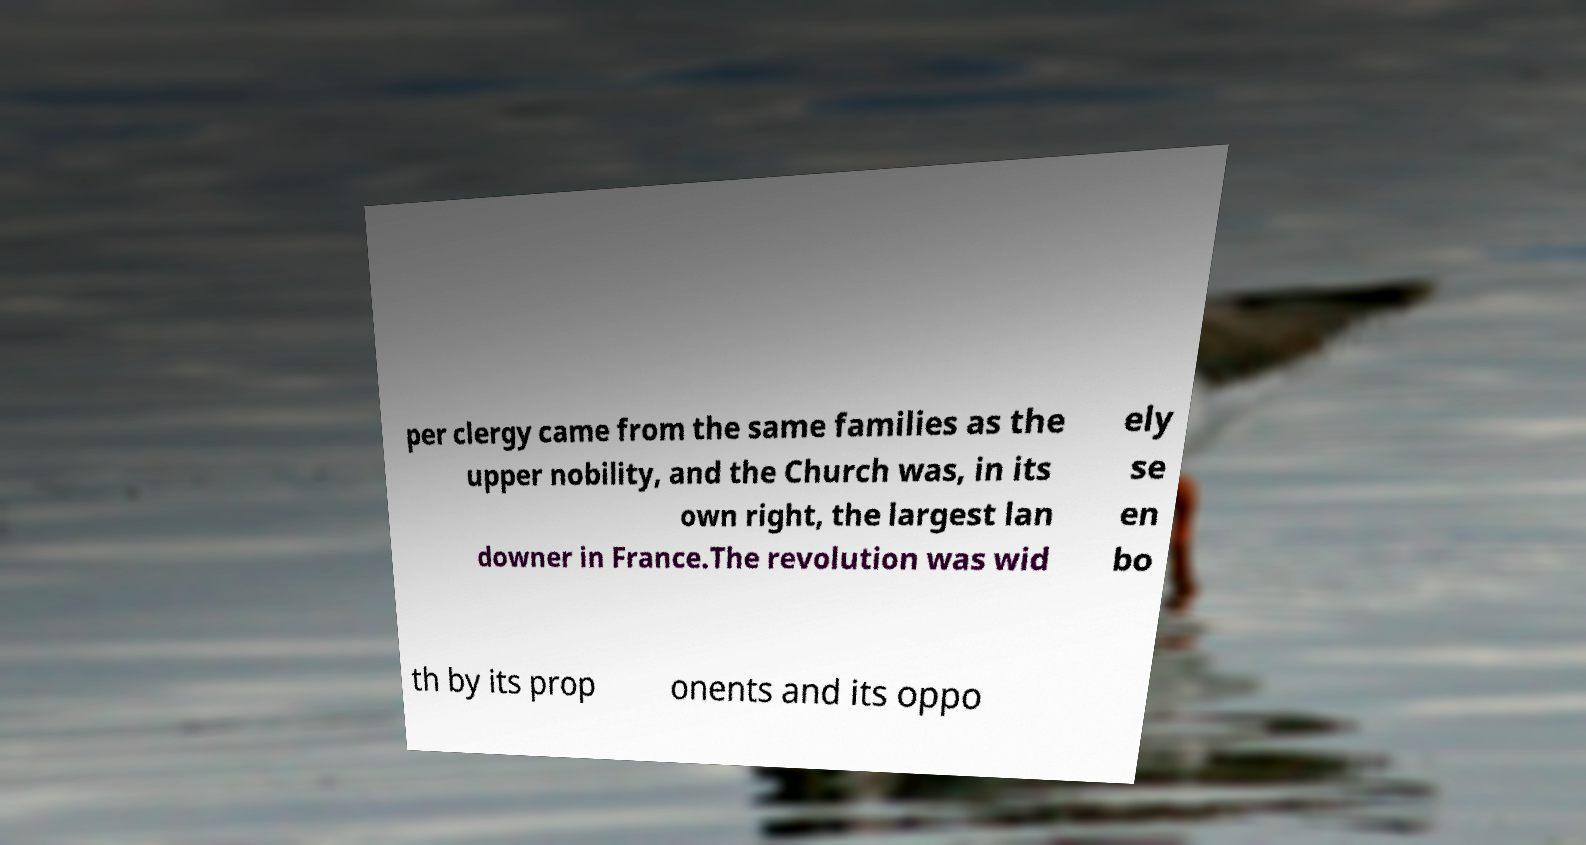What messages or text are displayed in this image? I need them in a readable, typed format. per clergy came from the same families as the upper nobility, and the Church was, in its own right, the largest lan downer in France.The revolution was wid ely se en bo th by its prop onents and its oppo 